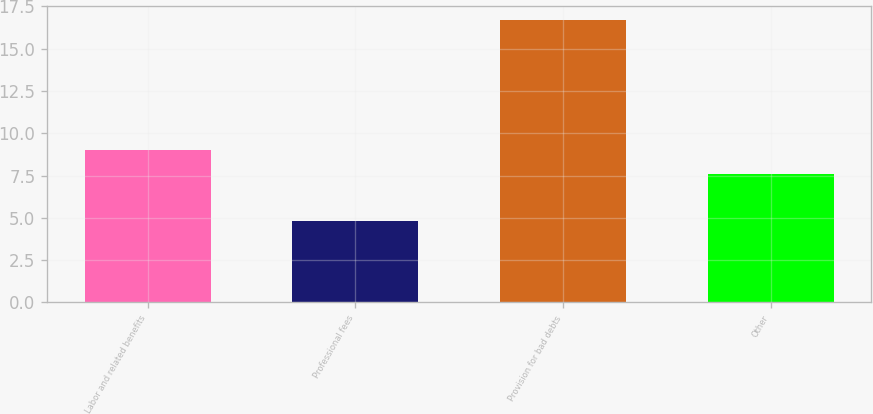<chart> <loc_0><loc_0><loc_500><loc_500><bar_chart><fcel>Labor and related benefits<fcel>Professional fees<fcel>Provision for bad debts<fcel>Other<nl><fcel>9<fcel>4.8<fcel>16.7<fcel>7.6<nl></chart> 